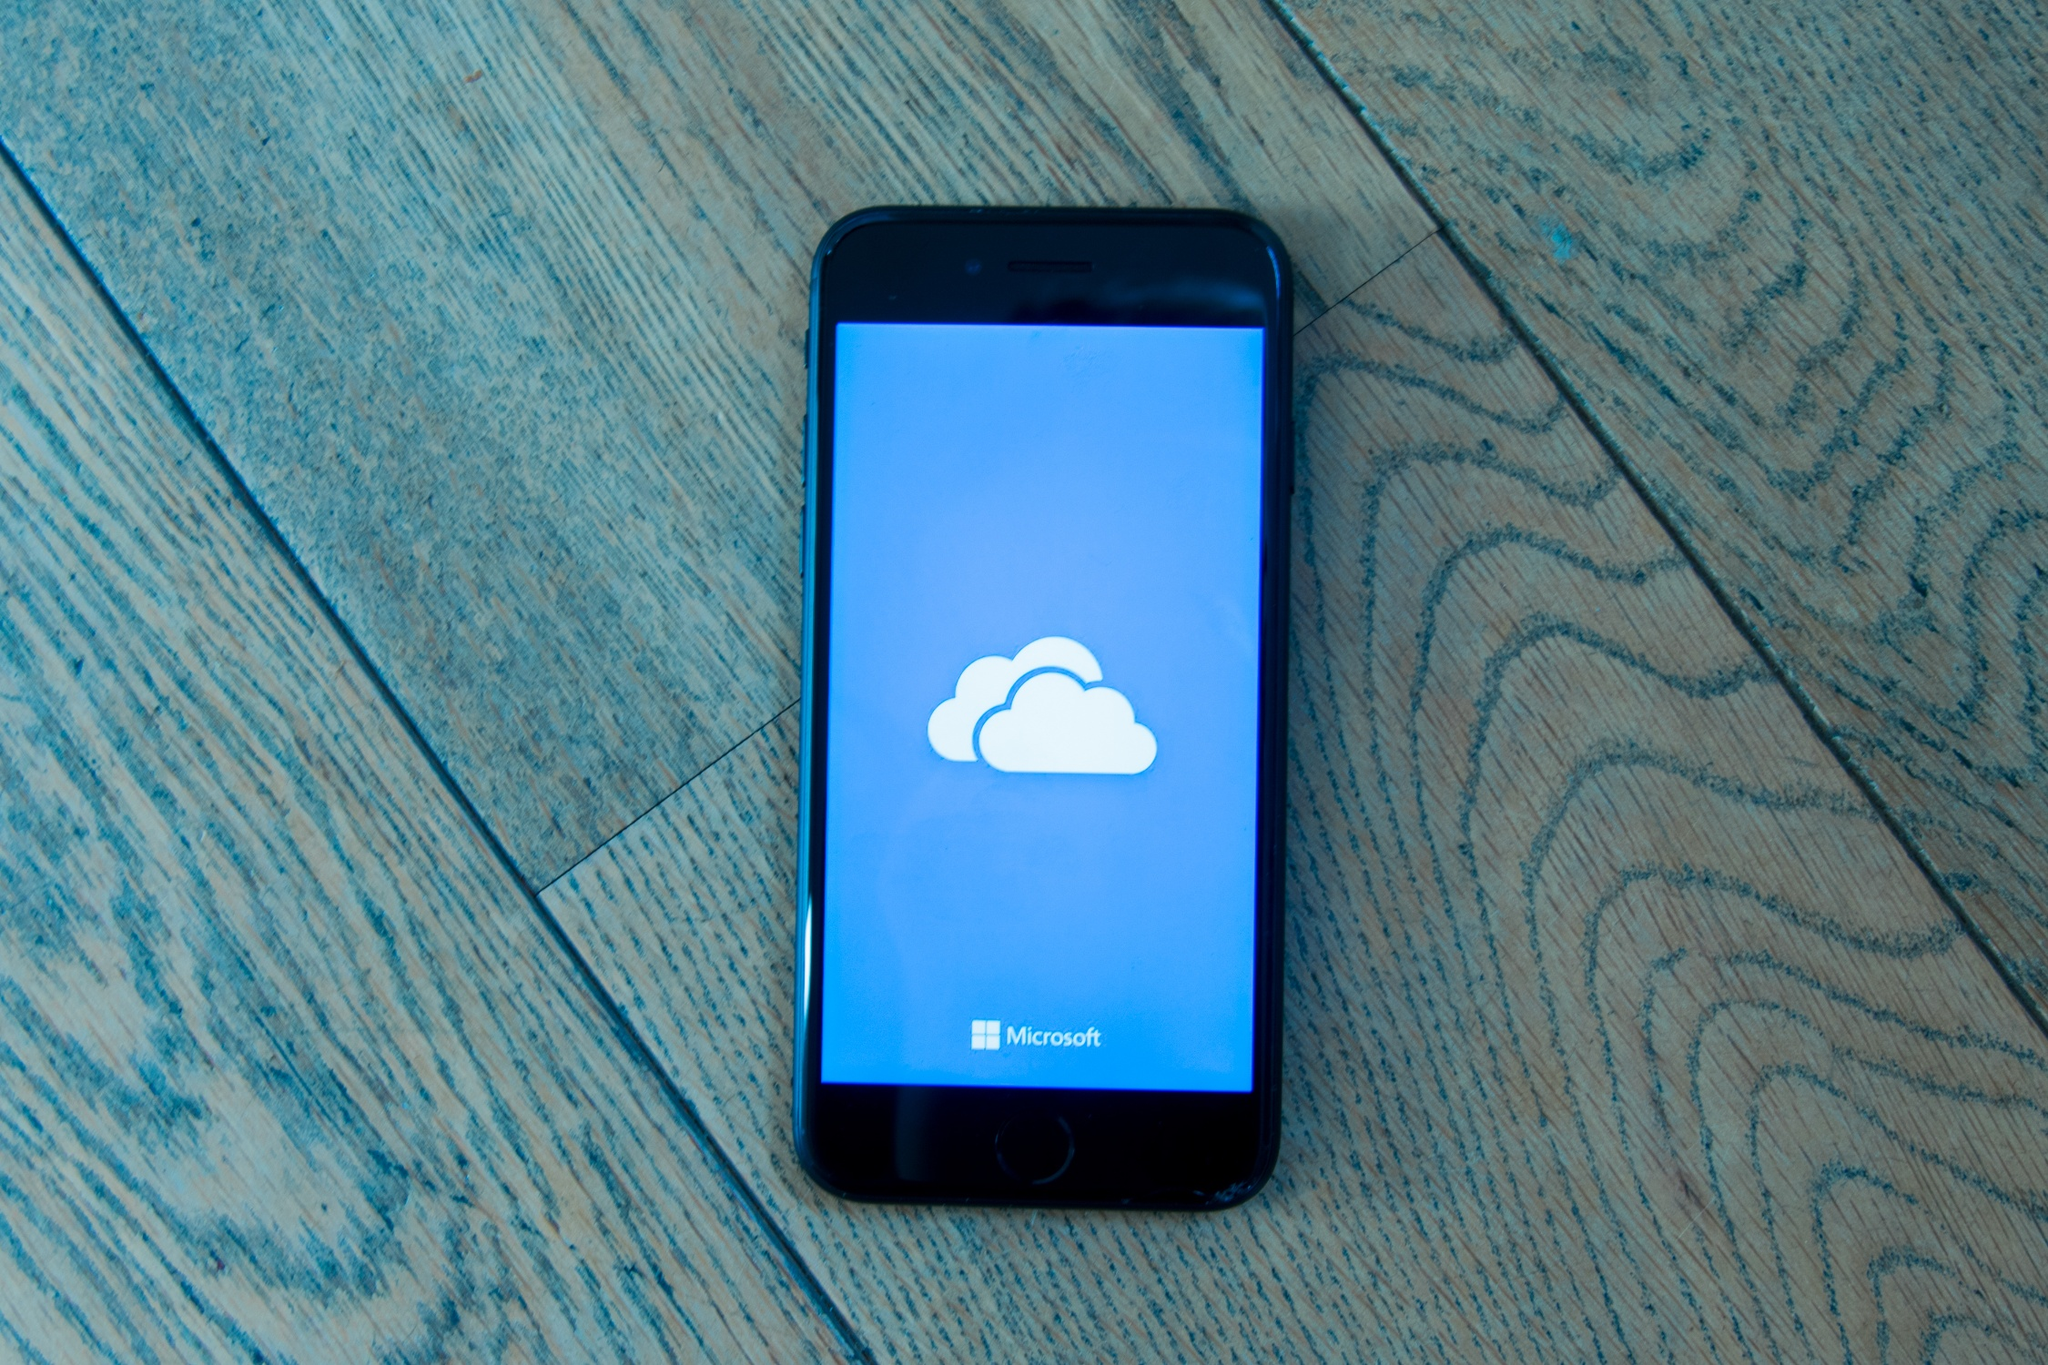Write a detailed description of the given image. This image features a black iPhone placed on a light-colored wooden floor that has a unique diagonal pattern, giving the scene a distinctive perspective. The iPhone itself is positioned diagonally, echoing the floor's pattern, which enhances the depth and casual feel of the composition. The phone's screen is turned on, displaying a vivid blue background with a prominent white cloud icon—a symbol commonly associated with cloud storage and services. Beneath the cloud icon, the word 'Microsoft' is clearly visible, written in black text that contrasts sharply against the blue background. This contrast makes the text highly readable and draws instant attention.

The photograph captures a seemingly spontaneous moment, as if the phone was either casually placed or perhaps dropped on the floor. Each element in the image is meticulously positioned to ensure the iPhone remains the focal point. There are no other objects present, which directs the viewer's entire focus to the phone and the message on its screen. The overall simplicity of the composition amplifies its primary elements, subtly communicating themes related to technology and Microsoft's cloud services. Through clever visual alignment and strategic use of color, the image successfully emphasizes the notion of digital storage and modern connectivity. 